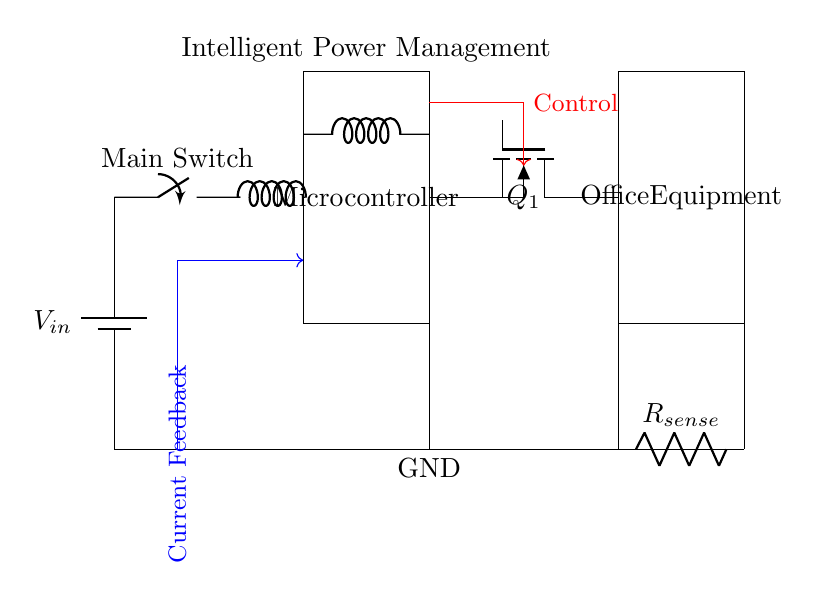What type of switch is used in this circuit? The circuit diagram specifies a "Main Switch," which is represented as a simple on-off switch in the schematic. Since it's labeled as a switch, it indicates that it controls the main power to the circuit.
Answer: Switch What is the role of the current sense resistor? The current sense resistor, labeled as R_sense, is typically used to monitor the current flowing through the load. By measuring the voltage across this resistor, the circuit can determine how much current is being drawn by the office equipment, enabling intelligent power management based on current usage.
Answer: Monitor current What component generates control signals in this circuit? The control signals are generated by the microcontroller, which is a central element in the circuit. It receives inputs and processes information to control the operation of the power MOSFET and manage the power to the office equipment.
Answer: Microcontroller Which component controls the power to the office equipment? The power MOSFET, labeled as Q1 in the diagram, is the component responsible for switching the power supply to the office equipment based on signals from the microcontroller, effectively managing power consumption.
Answer: Power MOSFET What is the supply voltage in this circuit? The supply voltage is indicated as V_in in the circuit diagram, but the exact numerical value isn't specified. However, it is the voltage provided from the battery to power the entire circuit, which generally would be in line with standard battery voltages.
Answer: V_in How does the circuit manage standby power reduction? The circuit uses an intelligent power management system that involves the microcontroller monitoring current usage through R_sense and controlling the MOSFET to disconnect power to the load when excess standby power is detected, thus effectively reducing energy consumption.
Answer: Intelligent power management 